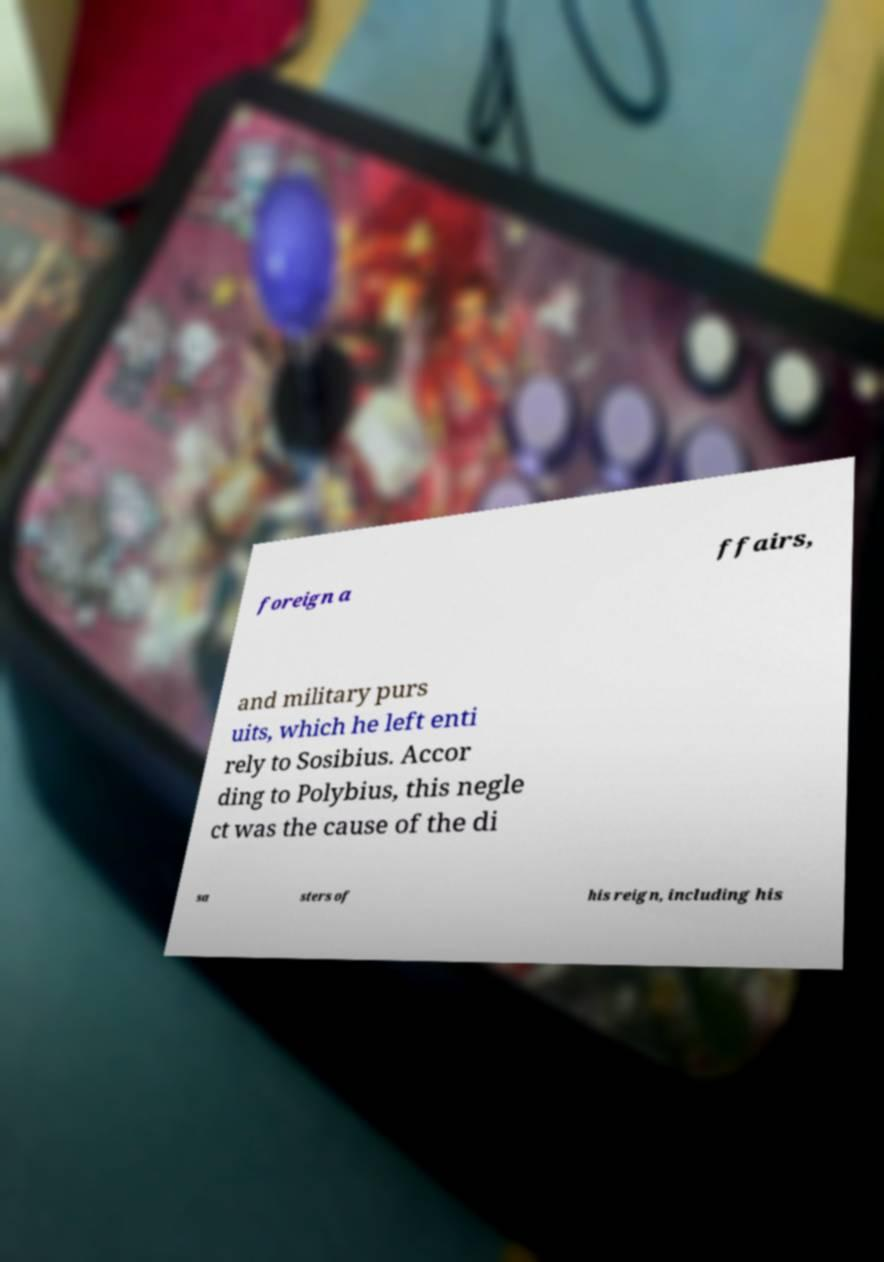I need the written content from this picture converted into text. Can you do that? foreign a ffairs, and military purs uits, which he left enti rely to Sosibius. Accor ding to Polybius, this negle ct was the cause of the di sa sters of his reign, including his 